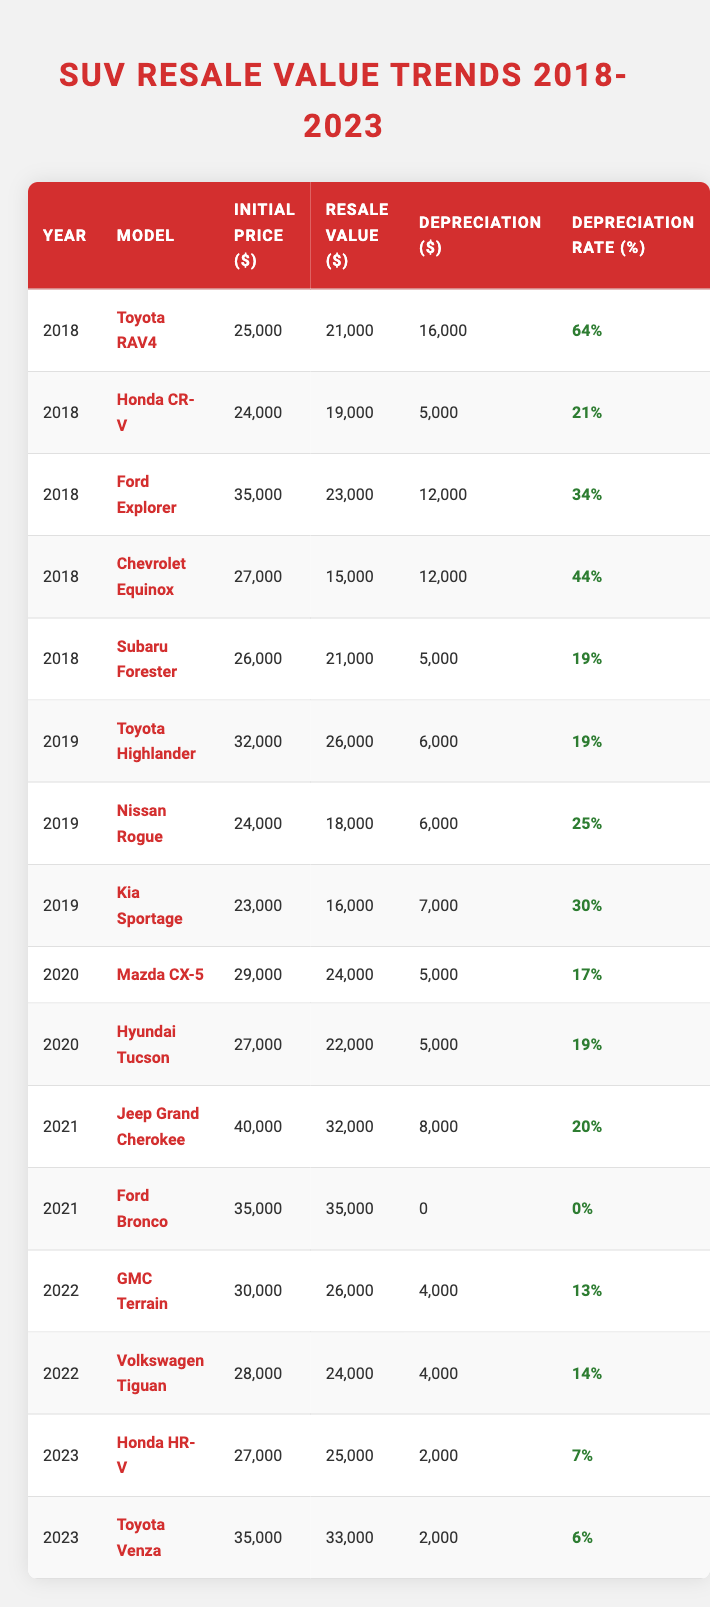What is the resale value of the 2022 GMC Terrain? The resale value for the 2022 GMC Terrain listed in the table is $26,000.
Answer: $26,000 Which SUV from 2018 had the highest depreciation rate? The Toyota RAV4 from 2018 has the highest depreciation rate at 64%.
Answer: 64% What is the average initial price of SUVs from 2019? For 2019, the initial prices are $32,000 (Toyota Highlander), $24,000 (Nissan Rogue), and $23,000 (Kia Sportage). The average is (32,000 + 24,000 + 23,000) / 3 = $26,333.
Answer: $26,333 Did the Ford Bronco depreciate in value? The Ford Bronco did not depreciate in value since its resale value equals its initial price at $35,000.
Answer: No What is the total depreciation of the 2018 Honda CR-V? The depreciation of the 2018 Honda CR-V is $5,000 as listed in the table.
Answer: $5,000 What is the difference in resale value between the 2023 Honda HR-V and the 2023 Toyota Venza? The resale value of the 2023 Honda HR-V is $25,000 and for the 2023 Toyota Venza, it is $33,000. The difference is $33,000 - $25,000 = $8,000.
Answer: $8,000 Which SUV has the lowest depreciation rate from 2021? The Ford Bronco in 2021 has the lowest depreciation rate at 0%, as it retained its full initial price.
Answer: 0% What is the median resale value of the SUVs listed from 2020? The resale values for 2020 are $24,000 (Mazda CX-5) and $22,000 (Hyundai Tucson). The median is the average of these two values, which is (24,000 + 22,000) / 2 = $23,000.
Answer: $23,000 How much depreciation does the 2023 Toyota Venza incur? The 2023 Toyota Venza incurs a depreciation of $2,000.
Answer: $2,000 What was the highest initial price for SUVs in 2021? The initial price for the Jeep Grand Cherokee in 2021 is $40,000, which is the highest among the SUVs listed for that year.
Answer: $40,000 